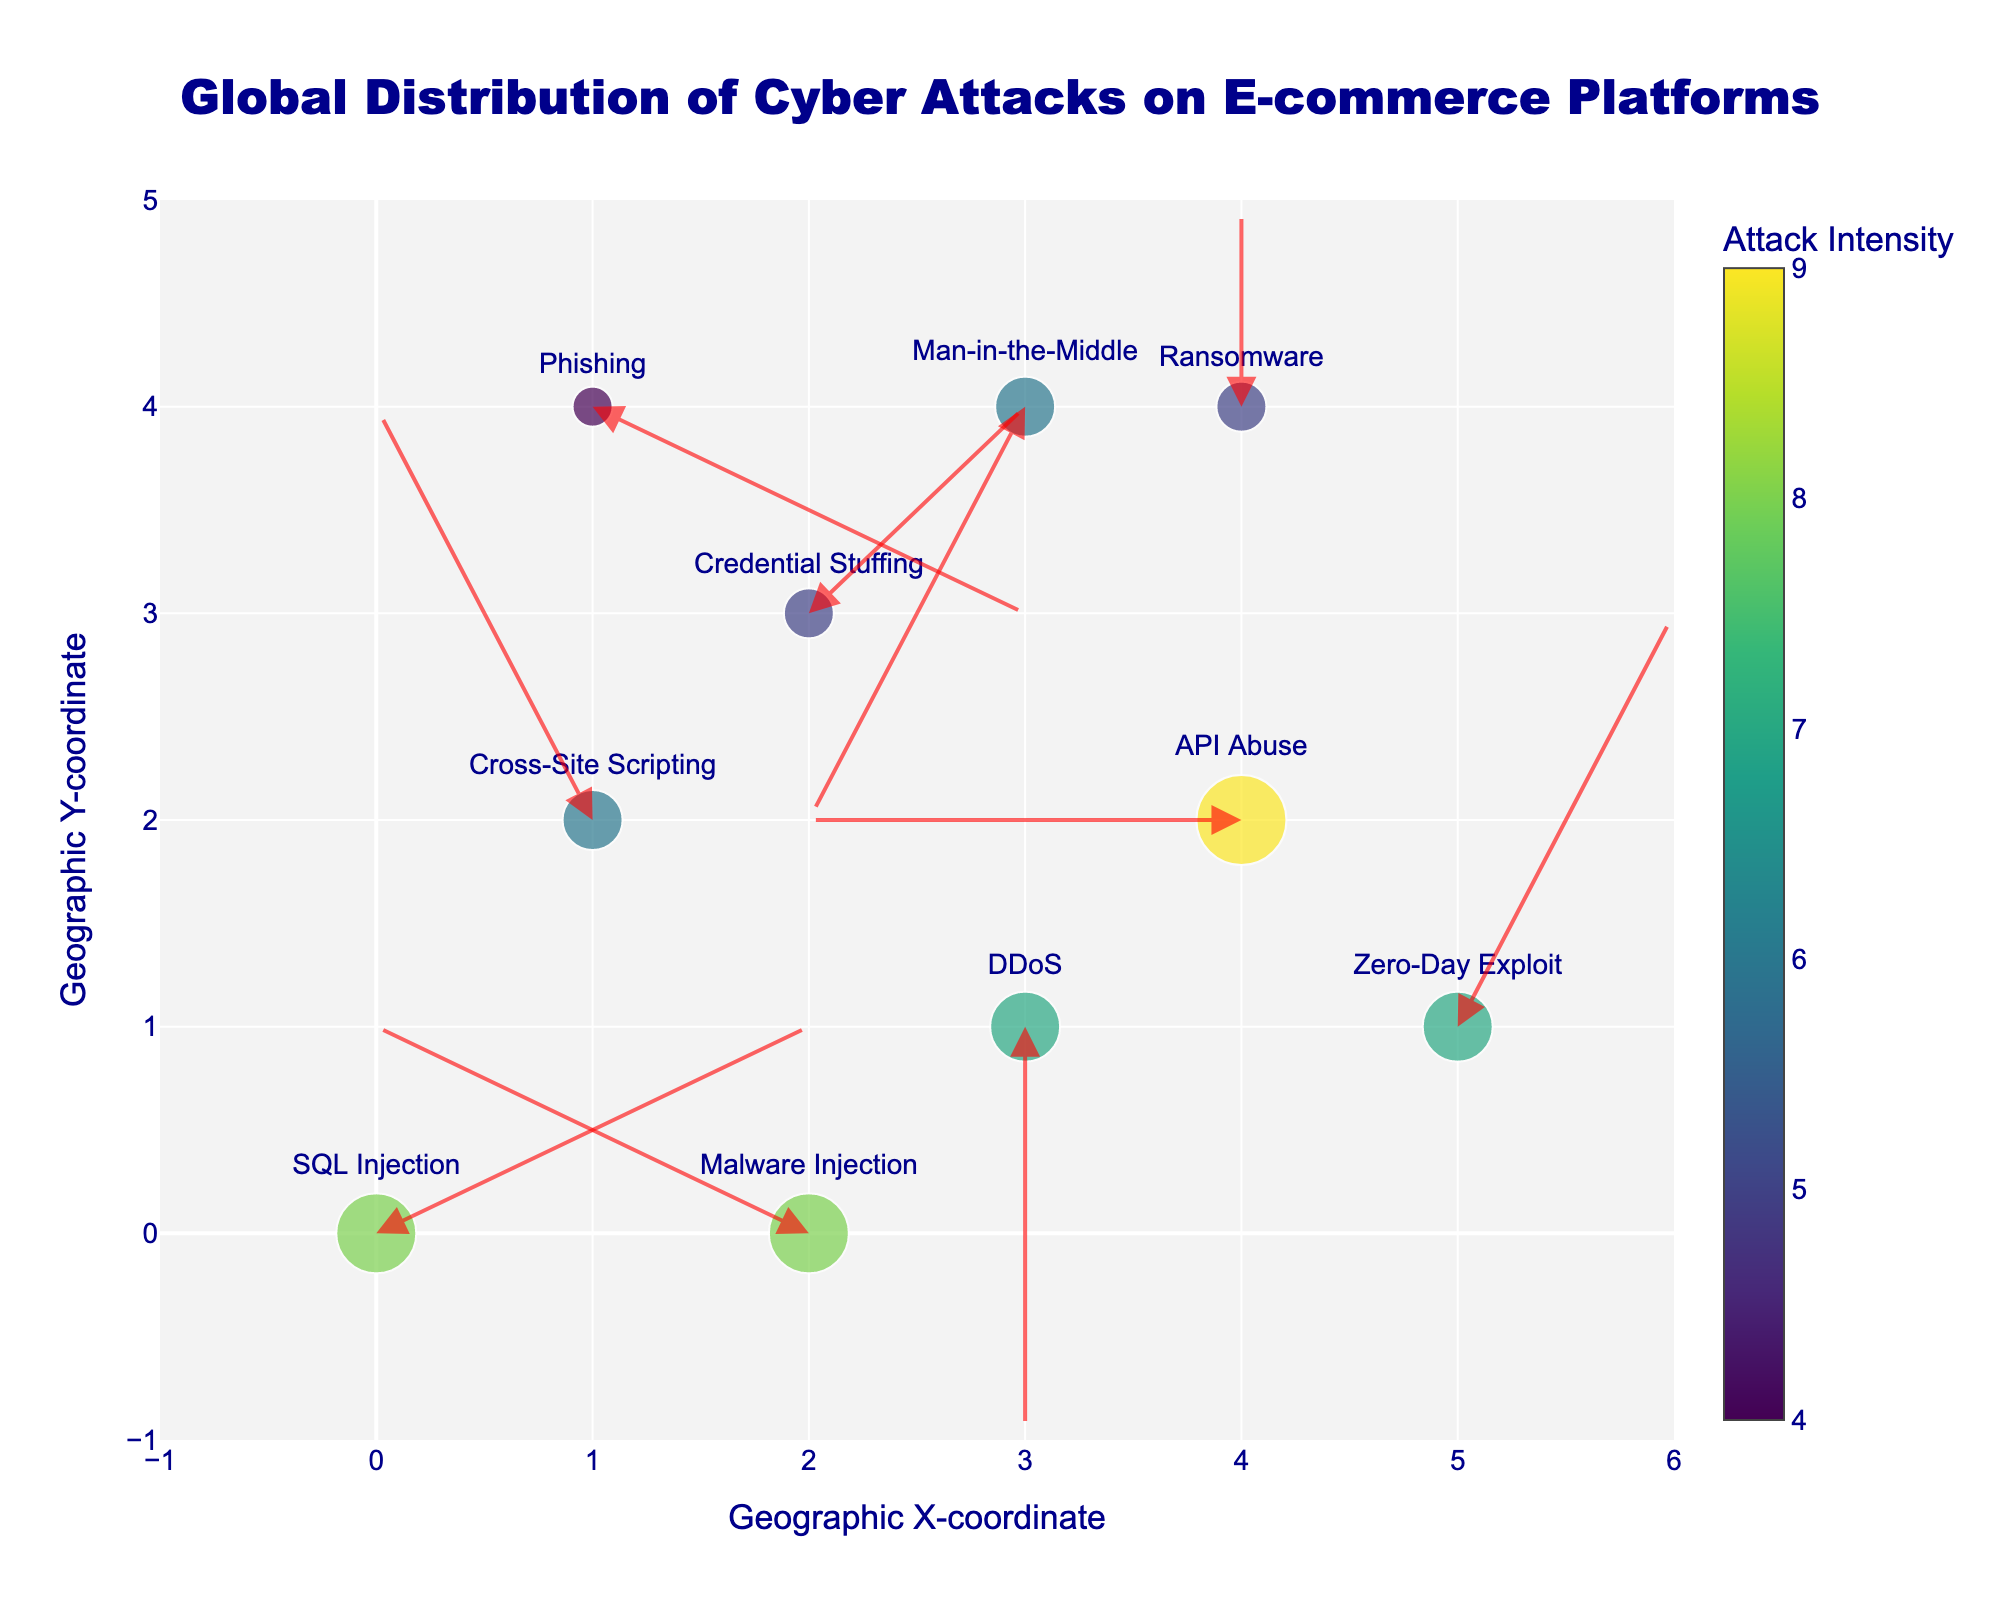what is the title of the figure? The title is located at the top of the figure, centralized, and in large, bold font. It reads "Global Distribution of Cyber Attacks on E-commerce Platforms".
Answer: Global Distribution of Cyber Attacks on E-commerce Platforms How many unique attack vectors are displayed in the plot? Each data point is labeled with an attack vector next to it. Count each unique label to get the total. The attack vectors are: "SQL Injection", "Cross-Site Scripting", "DDoS", "Credential Stuffing", "API Abuse", "Phishing", "Man-in-the-Middle", "Zero-Day Exploit", "Ransomware", "Malware Injection". There are 10 unique attack vectors.
Answer: 10 Which attack vector has the highest intensity value in the plot? Look at the color bar indicating attack intensities and match the color with the highest value to its corresponding attack vector. The darkest color corresponds to an intensity of 9 for "API Abuse".
Answer: API Abuse What is the direction of the arrow associated with "Credential Stuffing"? Find the "Credential Stuffing" label and observe the direction of its corresponding arrow. The arrow starts at (2, 3) and points to (3, 4), so it moves one unit to the right and one unit up.
Answer: Right and up Which attack vectors have arrows pointing downwards? Locate the labels of each attack vector and see if the arrows point downwards. "DDoS" has an arrow from (3, 1) to (3, -1) and "Man-in-the-Middle" has an arrow from (3, 4) to (2, 2).
Answer: DDoS, Man-in-the-Middle What is the total sum of intensities for attacks starting at x=1? Find all entries in the data where 'x' equals 1. These entries are (1, 2, 6, Cross-Site Scripting) and (1, 4, 4, Phishing). Sum their intensities: 6 + 4.
Answer: 10 Which attack vector has the longest arrow? Measure the length of each arrow using the distance formula sqrt(u^2 + v^2). The arrow lengths are:
- SQL Injection: sqrt(2^2 + 1^2) = sqrt(5)≈ 2.24
- Cross-Site Scripting: sqrt((-1)^2 + 2^2) = sqrt(5) ≈ 2.24
- DDoS: sqrt(0^2 + (-2)^2) = sqrt(4) = 2
- Credential Stuffing: sqrt(1^2 + 1^2) = sqrt(2) ≈ 1.41
- API Abuse: sqrt((-2)^2 + 0^2) = sqrt(4) = 2
- Phishing: sqrt(2^2 + (-1)^2) = sqrt(5) ≈ 2.24
- Man-in-the-Middle: sqrt((-1)^2 + (-2)^2) = sqrt(5) ≈ 2.24 
- Zero-Day Exploit: sqrt(1^2 + 2^2) = sqrt(5) ≈ 2.24
- Ransomware: sqrt(0^2 + 1^2) = 1
- Malware Injection: sqrt((-2)^2 + 1^2) = sqrt(5) ≈ 2.24
The longest arrows are associated with SQL Injection, Cross-Site Scripting, Phishing, Man-in-the-Middle, Zero-Day Exploit, and Malware Injection.
Answer: SQL Injection, Cross-Site Scripting, Phishing, Man-in-the-Middle, Zero-Day Exploit, Malware Injection How many attack vectors have an intensity of 5? Find all entries in the data where the 'intensity' equals 5. The entries are Credential Stuffing and Ransomware.
Answer: 2 What is the combined effect of "API Abuse" and "Phishing" on the x-coordinate? The "API Abuse" attack at (4, 2) moves left by 2, and "Phishing" attack at (1, 4) moves right by 2. Their combined effect is 0 on the x-coordinate as they cancel each other out.
Answer: 0 Does any data point have an arrow that does not affect its initial x-coordinate? Look for any arrows where the 'u' component (x-direction) is zero. The attack vector "DDoS" fits this criterion as it moves vertically but not horizontally.
Answer: DDoS 